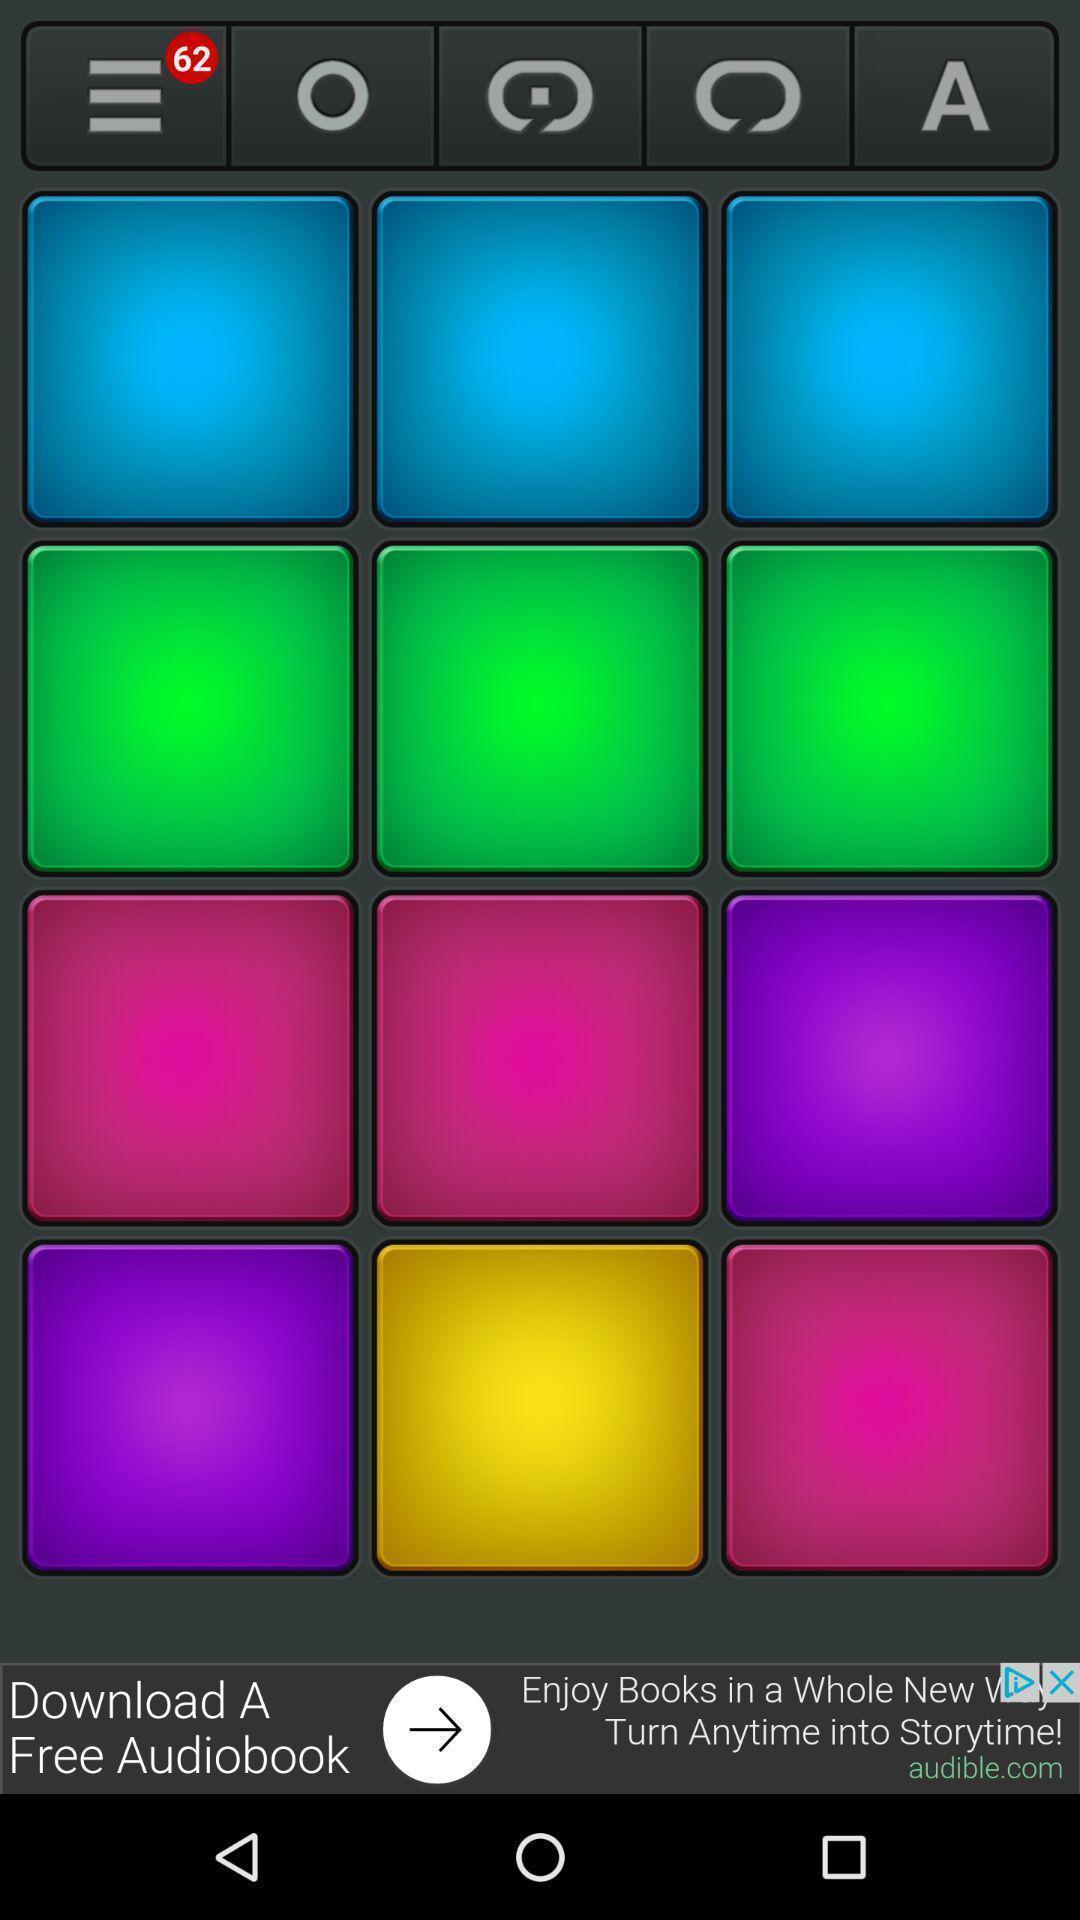Summarize the main components in this picture. Screen page of a music mixer app. 